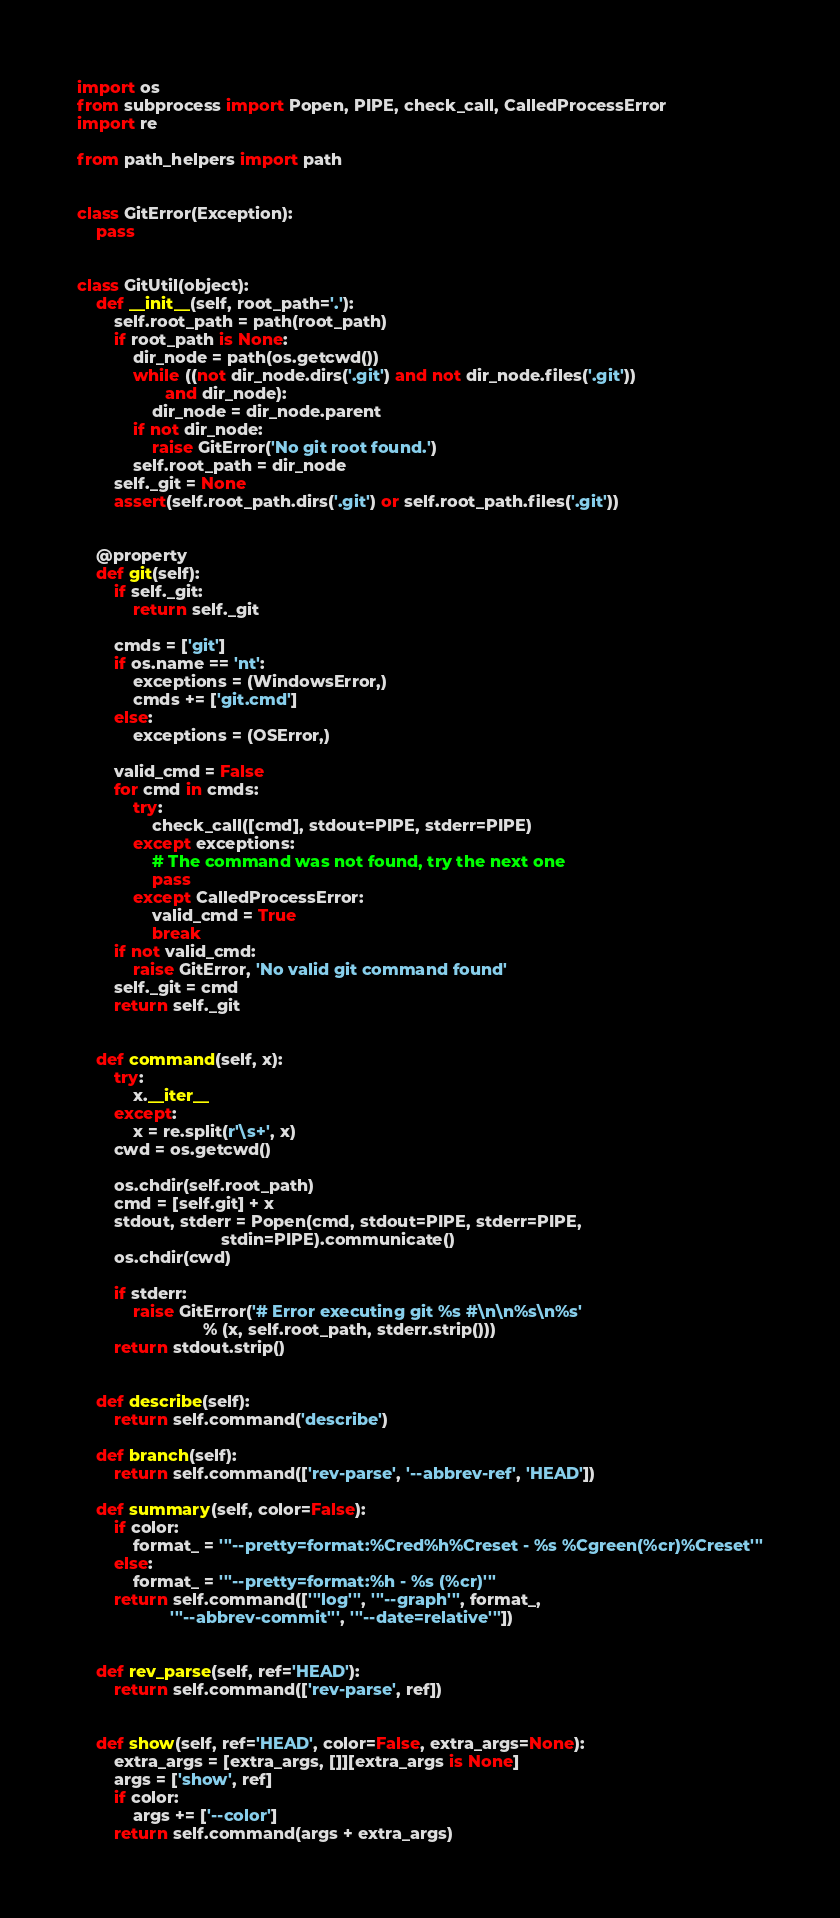Convert code to text. <code><loc_0><loc_0><loc_500><loc_500><_Python_>import os
from subprocess import Popen, PIPE, check_call, CalledProcessError
import re

from path_helpers import path


class GitError(Exception):
    pass


class GitUtil(object):
    def __init__(self, root_path='.'):
        self.root_path = path(root_path)
        if root_path is None:
            dir_node = path(os.getcwd())
            while ((not dir_node.dirs('.git') and not dir_node.files('.git'))
                   and dir_node):
                dir_node = dir_node.parent
            if not dir_node:
                raise GitError('No git root found.')
            self.root_path = dir_node
        self._git = None
        assert(self.root_path.dirs('.git') or self.root_path.files('.git'))


    @property
    def git(self):
        if self._git:
            return self._git

        cmds = ['git']
        if os.name == 'nt':
            exceptions = (WindowsError,)
            cmds += ['git.cmd']
        else:
            exceptions = (OSError,)

        valid_cmd = False
        for cmd in cmds:
            try:
                check_call([cmd], stdout=PIPE, stderr=PIPE)
            except exceptions:
                # The command was not found, try the next one
                pass
            except CalledProcessError:
                valid_cmd = True
                break
        if not valid_cmd:
            raise GitError, 'No valid git command found'
        self._git = cmd
        return self._git


    def command(self, x):
        try:
            x.__iter__
        except:
            x = re.split(r'\s+', x)
        cwd = os.getcwd()

        os.chdir(self.root_path)
        cmd = [self.git] + x
        stdout, stderr = Popen(cmd, stdout=PIPE, stderr=PIPE,
                               stdin=PIPE).communicate()
        os.chdir(cwd)

        if stderr:
            raise GitError('# Error executing git %s #\n\n%s\n%s'
                           % (x, self.root_path, stderr.strip()))
        return stdout.strip()


    def describe(self):
        return self.command('describe')

    def branch(self):
        return self.command(['rev-parse', '--abbrev-ref', 'HEAD'])

    def summary(self, color=False):
        if color:
            format_ = '''--pretty=format:%Cred%h%Creset - %s %Cgreen(%cr)%Creset'''
        else:
            format_ = '''--pretty=format:%h - %s (%cr)'''
        return self.command(['''log''', '''--graph''', format_,
                    '''--abbrev-commit''', '''--date=relative'''])


    def rev_parse(self, ref='HEAD'):
        return self.command(['rev-parse', ref])


    def show(self, ref='HEAD', color=False, extra_args=None):
        extra_args = [extra_args, []][extra_args is None]
        args = ['show', ref]
        if color:
            args += ['--color']
        return self.command(args + extra_args)
</code> 